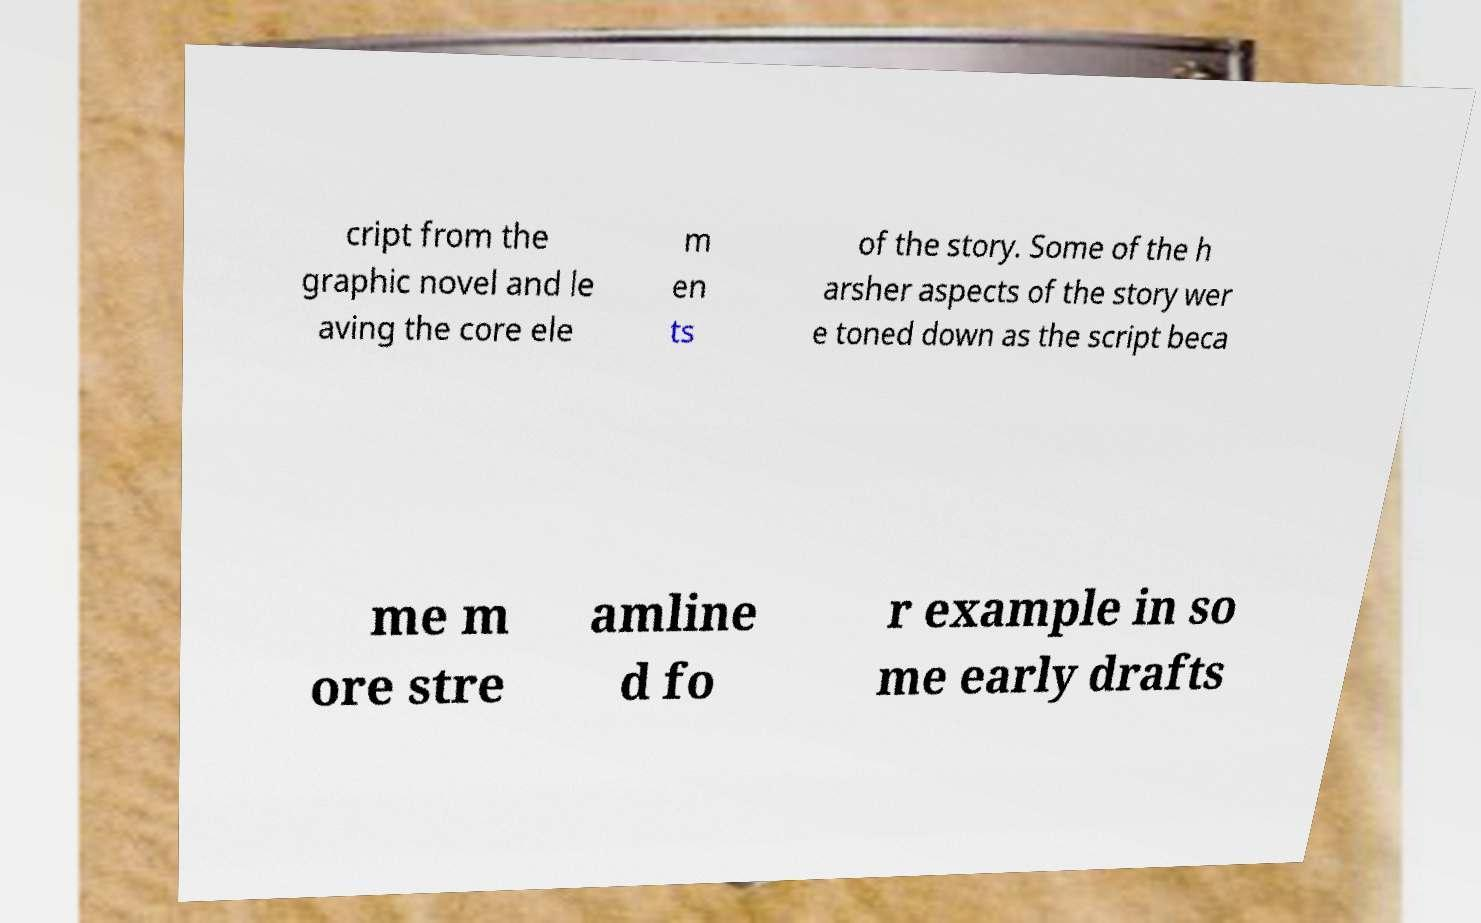There's text embedded in this image that I need extracted. Can you transcribe it verbatim? cript from the graphic novel and le aving the core ele m en ts of the story. Some of the h arsher aspects of the story wer e toned down as the script beca me m ore stre amline d fo r example in so me early drafts 